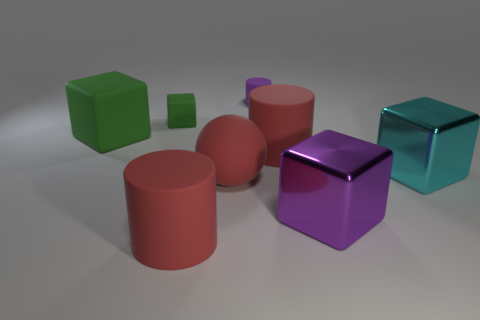Is there any other thing that is the same size as the cyan shiny thing?
Provide a short and direct response. Yes. What material is the green cube that is the same size as the cyan metal block?
Ensure brevity in your answer.  Rubber. Are there any purple matte things that have the same size as the purple cylinder?
Offer a very short reply. No. What is the size of the purple thing that is in front of the purple cylinder?
Make the answer very short. Large. What size is the cyan object?
Make the answer very short. Large. What number of cylinders are large cyan things or large things?
Provide a short and direct response. 2. There is a thing that is the same material as the cyan cube; what is its size?
Your answer should be compact. Large. How many big objects have the same color as the rubber sphere?
Ensure brevity in your answer.  2. Are there any small purple cylinders right of the purple metal cube?
Offer a terse response. No. Do the small purple rubber thing and the small thing that is left of the tiny purple cylinder have the same shape?
Offer a terse response. No. 